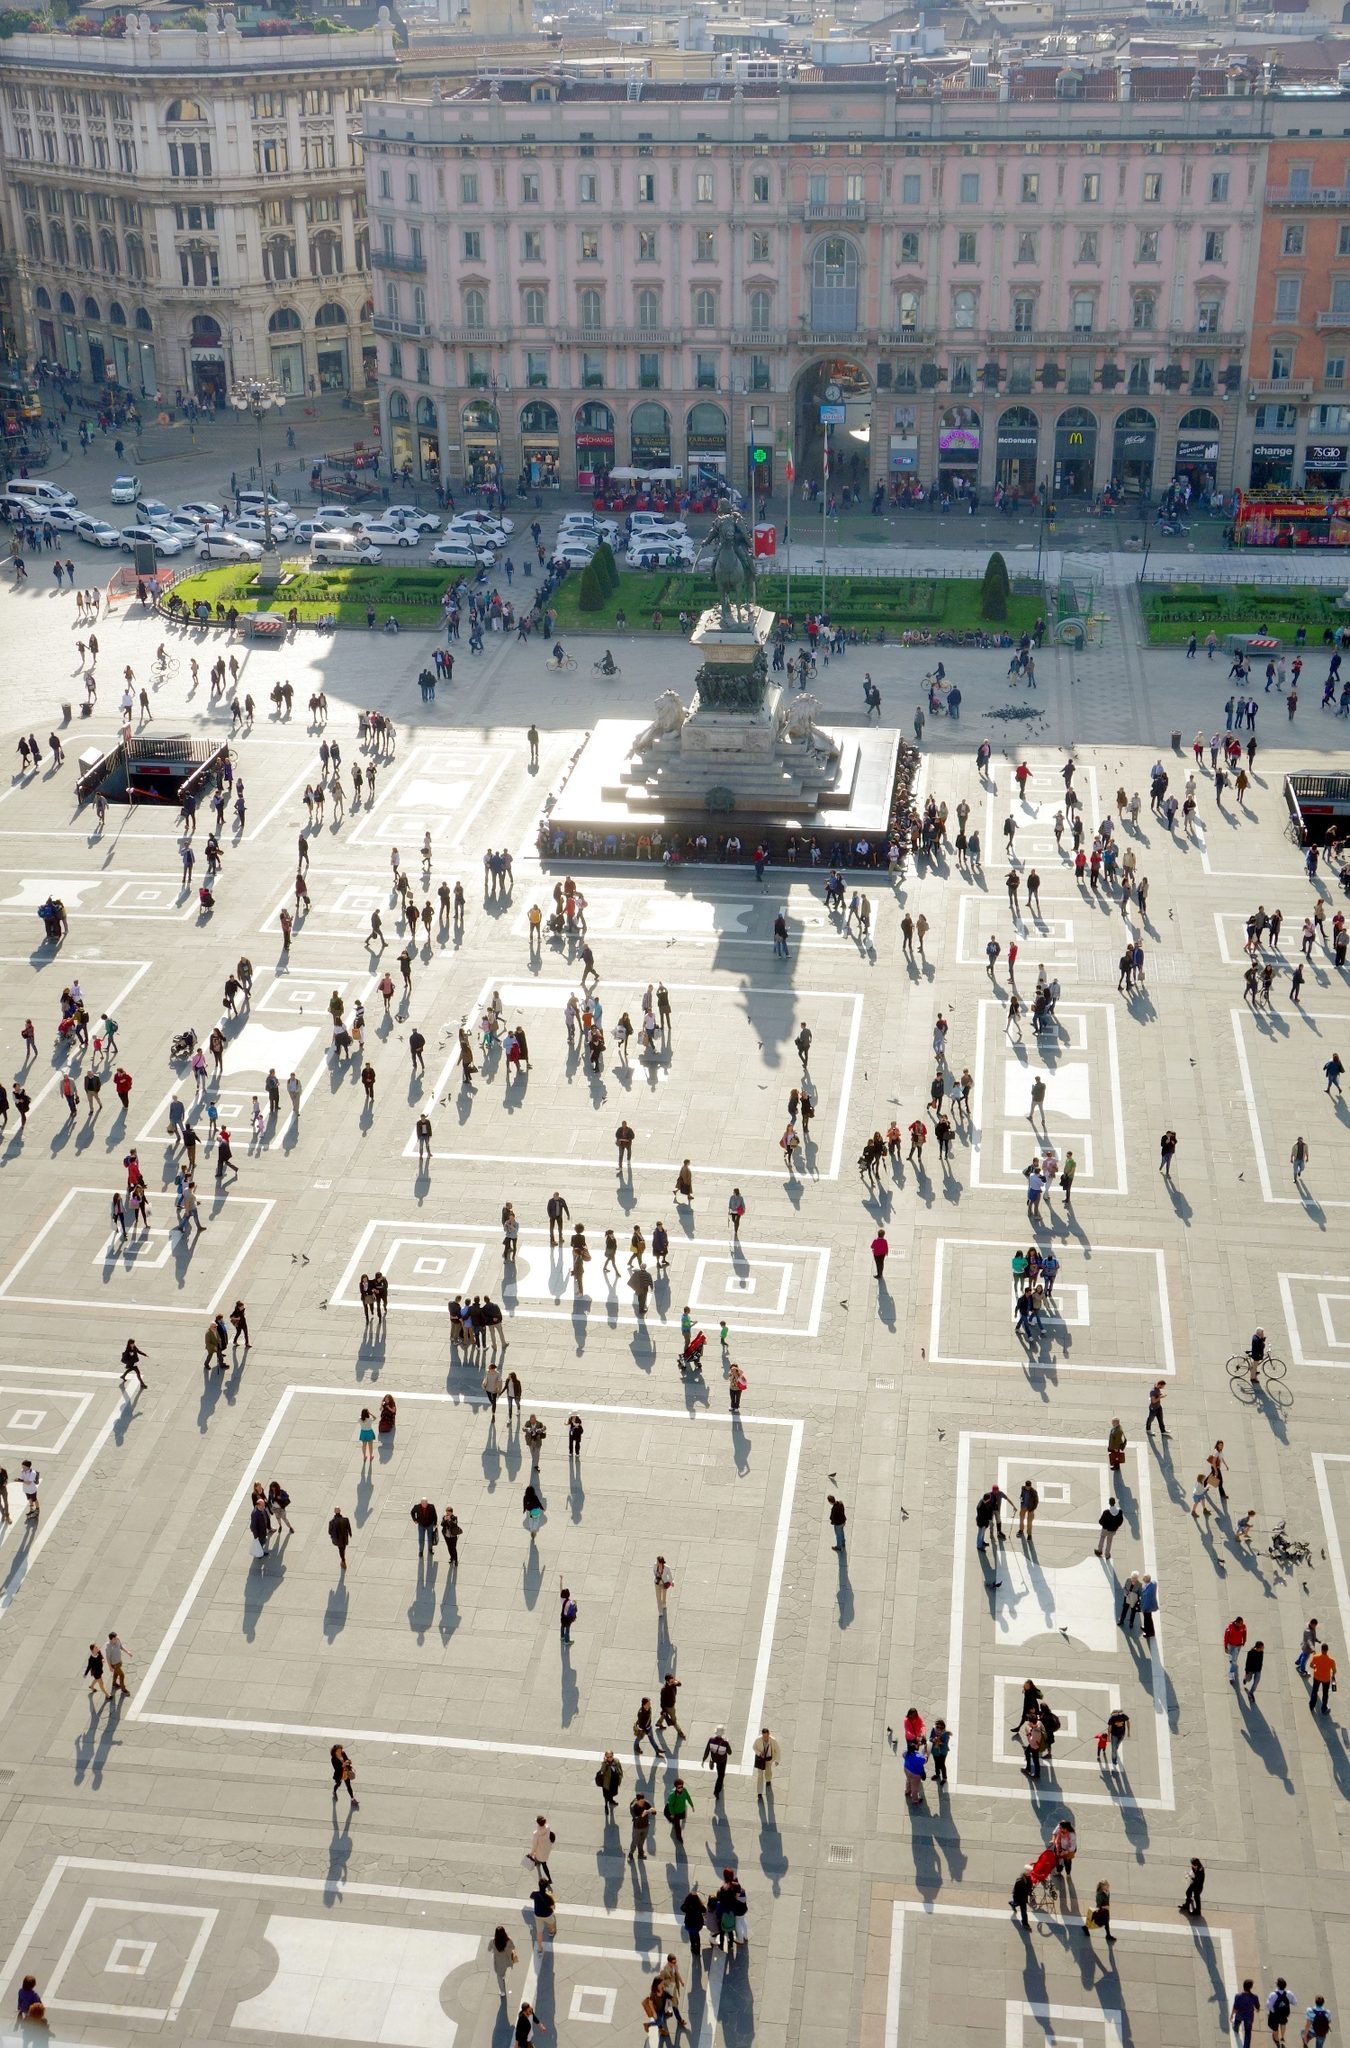What do you think this piazza might look like 100 years into the future? A century into the future, the Piazza del Duomo might blend its revered historical architecture with modern advancements. Imagining a sleek, transparent dome spanning the square, protecting it while enhancing the view of the magnificent Duomo, perhaps advanced holographic displays provide information about the history of the site. Self-cleaning pavements and eco-friendly public transportation systems ensure a sustainable approach to maintaining the bustling activities. The surrounding buildings may retain their classical facades, internally reconfigured to blend heritage with the epitome of technological advancements. Such visionary integration would allow the plaza to honor its historical legacy while embracing a futuristic transformation. 